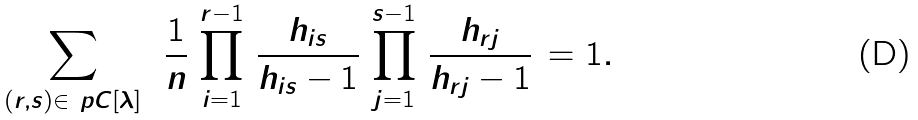Convert formula to latex. <formula><loc_0><loc_0><loc_500><loc_500>\sum _ { ( r , s ) \in \ p C [ \lambda ] } \ \, \frac { 1 } { n } \, \prod _ { i = 1 } ^ { r - 1 } \, \frac { h _ { i s } } { h _ { i s } - 1 } \, \prod _ { j = 1 } ^ { s - 1 } \, \frac { h _ { r j } } { h _ { r j } - 1 } \, = 1 .</formula> 